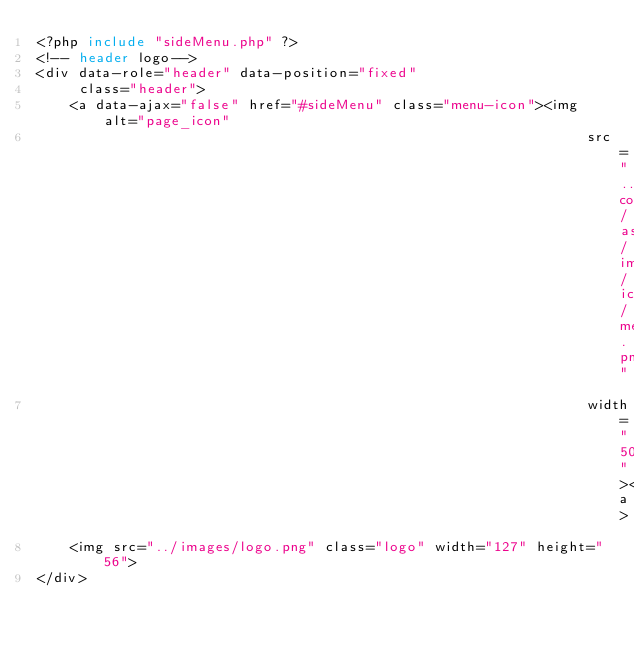<code> <loc_0><loc_0><loc_500><loc_500><_PHP_><?php include "sideMenu.php" ?>
<!-- header logo-->
<div data-role="header" data-position="fixed"
     class="header">
    <a data-ajax="false" href="#sideMenu" class="menu-icon"><img alt="page_icon"
                                                                 src="../../common/assets/images/icons/menu.png"
                                                                 width="50"></a>
    <img src="../images/logo.png" class="logo" width="127" height="56">
</div></code> 